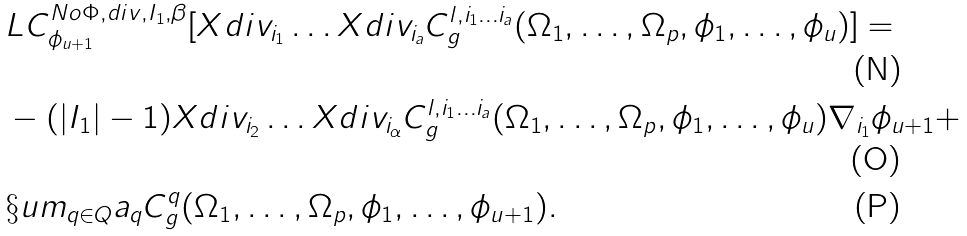Convert formula to latex. <formula><loc_0><loc_0><loc_500><loc_500>& L C ^ { N o \Phi , d i v , I _ { 1 } , \beta } _ { \phi _ { u + 1 } } [ X d i v _ { i _ { 1 } } \dots X d i v _ { i _ { a } } C ^ { l , i _ { 1 } \dots i _ { a } } _ { g } ( \Omega _ { 1 } , \dots , \Omega _ { p } , \phi _ { 1 } , \dots , \phi _ { u } ) ] = \\ & - ( | I _ { 1 } | - 1 ) X d i v _ { i _ { 2 } } \dots X d i v _ { i _ { \alpha } } C ^ { l , i _ { 1 } \dots i _ { a } } _ { g } ( \Omega _ { 1 } , \dots , \Omega _ { p } , \phi _ { 1 } , \dots , \phi _ { u } ) \nabla _ { i _ { 1 } } \phi _ { u + 1 } + \\ & \S u m _ { q \in Q } a _ { q } C ^ { q } _ { g } ( \Omega _ { 1 } , \dots , \Omega _ { p } , \phi _ { 1 } , \dots , \phi _ { u + 1 } ) .</formula> 